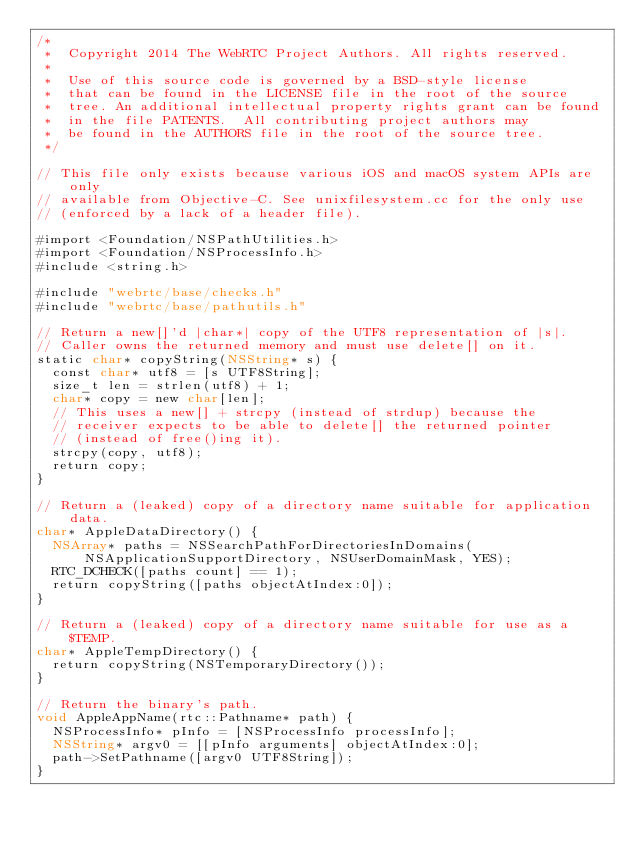Convert code to text. <code><loc_0><loc_0><loc_500><loc_500><_ObjectiveC_>/*
 *  Copyright 2014 The WebRTC Project Authors. All rights reserved.
 *
 *  Use of this source code is governed by a BSD-style license
 *  that can be found in the LICENSE file in the root of the source
 *  tree. An additional intellectual property rights grant can be found
 *  in the file PATENTS.  All contributing project authors may
 *  be found in the AUTHORS file in the root of the source tree.
 */

// This file only exists because various iOS and macOS system APIs are only
// available from Objective-C. See unixfilesystem.cc for the only use
// (enforced by a lack of a header file).

#import <Foundation/NSPathUtilities.h>
#import <Foundation/NSProcessInfo.h>
#include <string.h>

#include "webrtc/base/checks.h"
#include "webrtc/base/pathutils.h"

// Return a new[]'d |char*| copy of the UTF8 representation of |s|.
// Caller owns the returned memory and must use delete[] on it.
static char* copyString(NSString* s) {
  const char* utf8 = [s UTF8String];
  size_t len = strlen(utf8) + 1;
  char* copy = new char[len];
  // This uses a new[] + strcpy (instead of strdup) because the
  // receiver expects to be able to delete[] the returned pointer
  // (instead of free()ing it).
  strcpy(copy, utf8);
  return copy;
}

// Return a (leaked) copy of a directory name suitable for application data.
char* AppleDataDirectory() {
  NSArray* paths = NSSearchPathForDirectoriesInDomains(
      NSApplicationSupportDirectory, NSUserDomainMask, YES);
  RTC_DCHECK([paths count] == 1);
  return copyString([paths objectAtIndex:0]);
}

// Return a (leaked) copy of a directory name suitable for use as a $TEMP.
char* AppleTempDirectory() {
  return copyString(NSTemporaryDirectory());
}

// Return the binary's path.
void AppleAppName(rtc::Pathname* path) {
  NSProcessInfo* pInfo = [NSProcessInfo processInfo];
  NSString* argv0 = [[pInfo arguments] objectAtIndex:0];
  path->SetPathname([argv0 UTF8String]);
}
</code> 